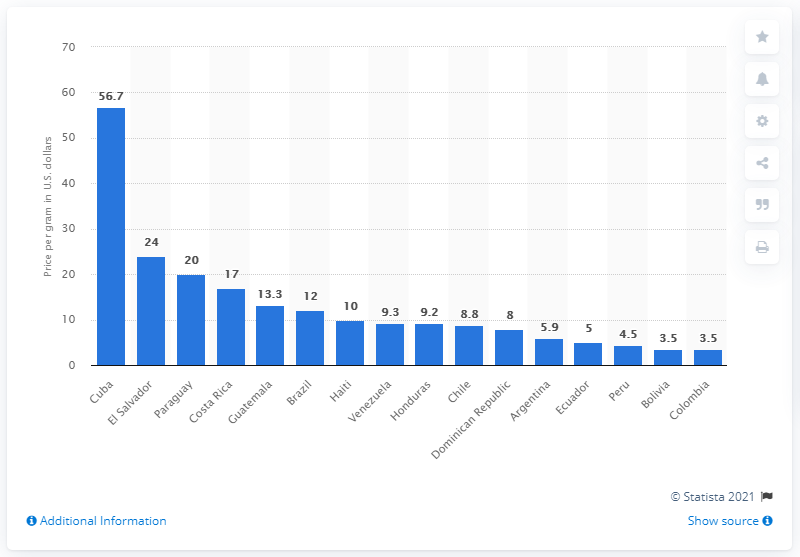Draw attention to some important aspects in this diagram. In 2016, the highest selling price of cocaine in Latin America was in Cuba, according to a report. In 2016, the average selling price per gram of cocaine in Cuba was 56.7 USD. 